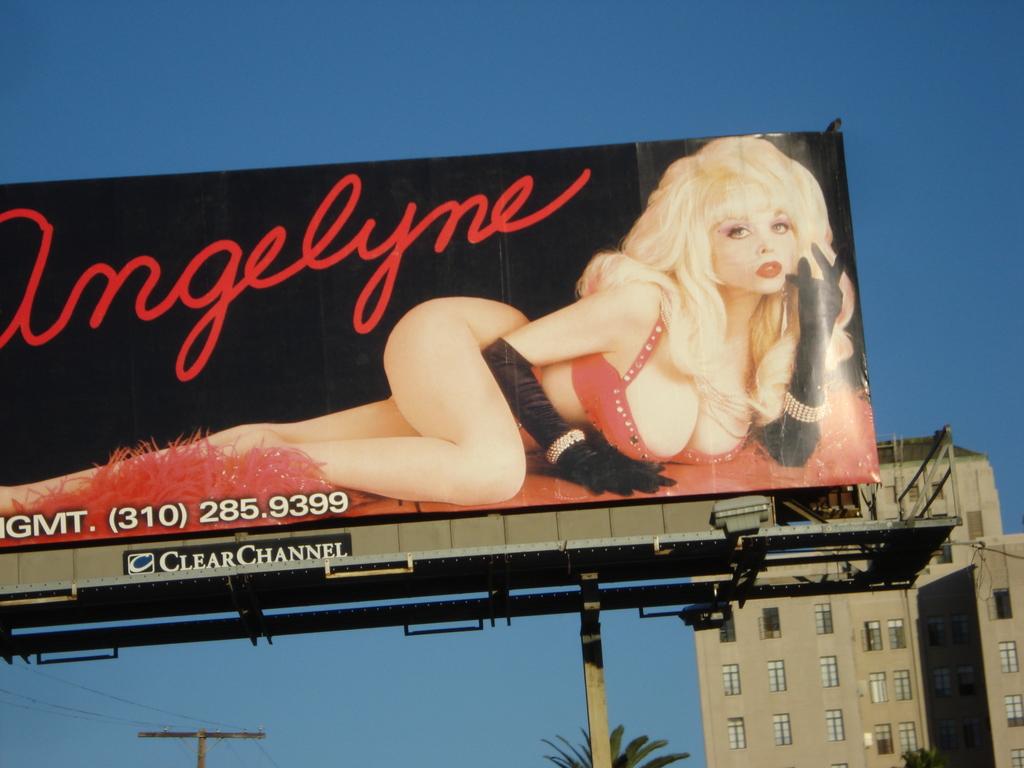What is the phone number shown on the advertisement board?
Provide a short and direct response. (310) 285.9399. 